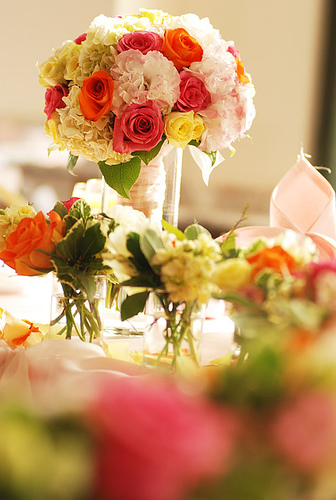<image>
Is there a rose next to the lily? Yes. The rose is positioned adjacent to the lily, located nearby in the same general area. 